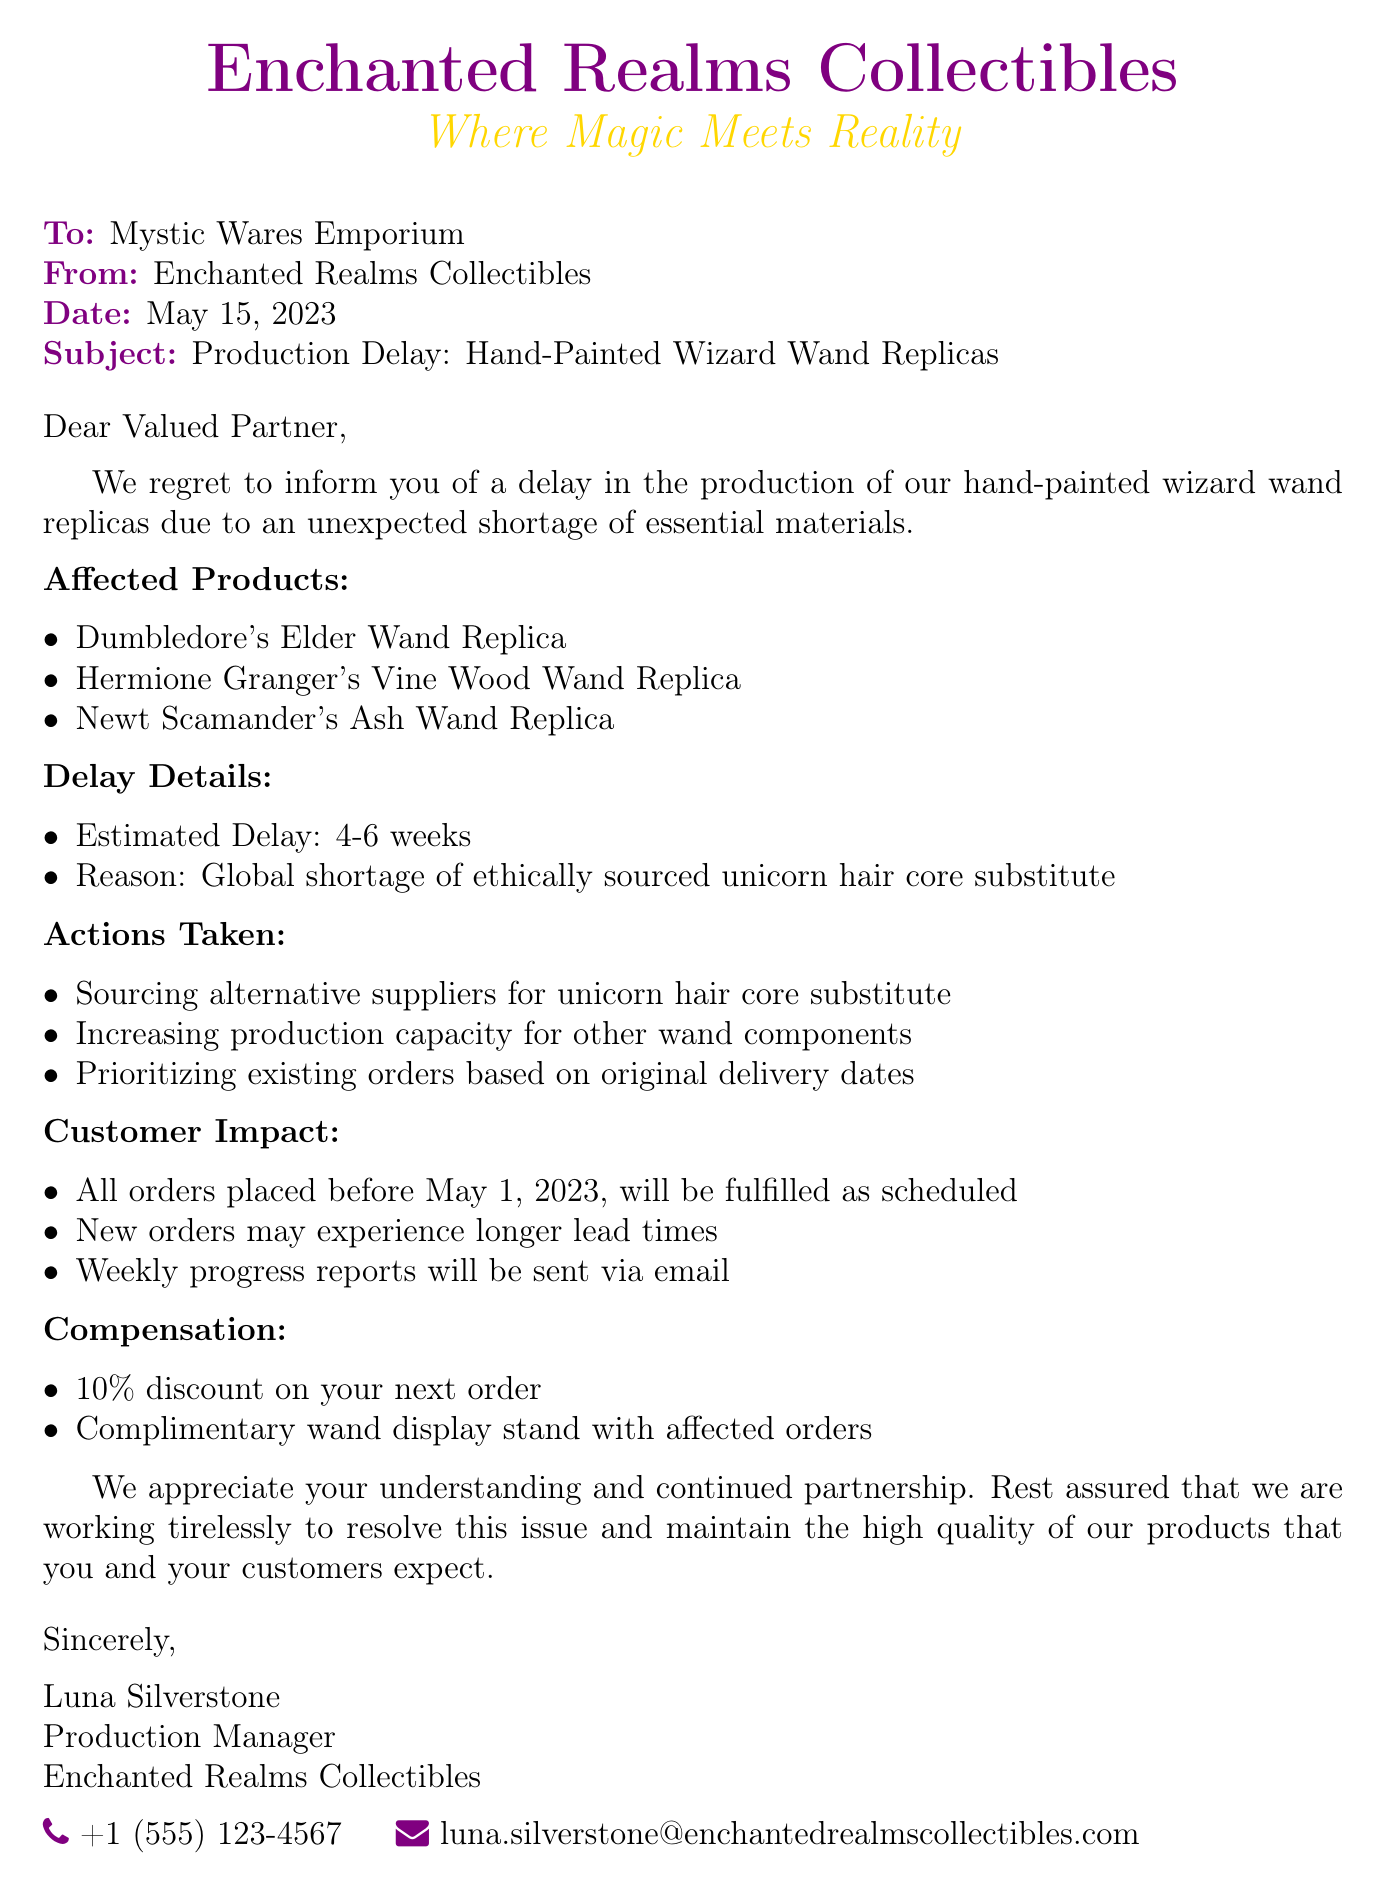what is the subject of the fax? The subject summarizes the primary topic of the fax, which is about production delays.
Answer: Production Delay: Hand-Painted Wizard Wand Replicas who is the sender of the fax? The sender is the organization that issued the fax, providing their name.
Answer: Enchanted Realms Collectibles what is the estimated delay for production? The estimated delay indicates how long the production will be postponed due to material shortages.
Answer: 4-6 weeks what specific material shortage is mentioned? The document specifies the type of material that is in short supply for production.
Answer: ethically sourced unicorn hair core substitute what discount is offered as compensation? The compensation section outlines the benefits provided to the recipient for the inconvenience caused.
Answer: 10% discount how many products are listed as affected? This number refers to the total items mentioned as being impacted by the delay.
Answer: 3 what is the reason for the production delay? The reason explains the underlying issue causing the delay in production.
Answer: Global shortage of ethically sourced unicorn hair core substitute who is the Production Manager? This identifies the individual responsible for production who signed the document.
Answer: Luna Silverstone what will happen to new orders? This indicates the impact of the delay on future orders placed after a specific date.
Answer: may experience longer lead times 